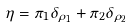<formula> <loc_0><loc_0><loc_500><loc_500>\eta = \pi _ { 1 } \delta _ { \rho _ { 1 } } + \pi _ { 2 } \delta _ { \rho _ { 2 } }</formula> 